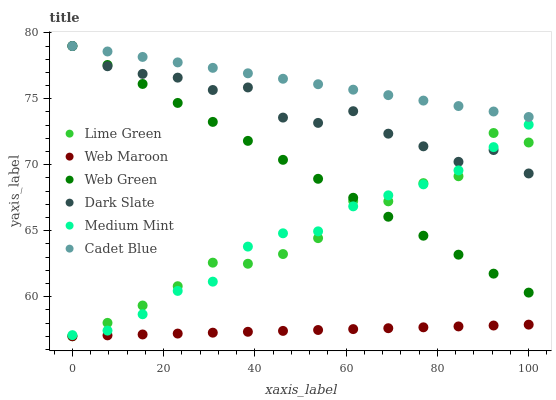Does Web Maroon have the minimum area under the curve?
Answer yes or no. Yes. Does Cadet Blue have the maximum area under the curve?
Answer yes or no. Yes. Does Cadet Blue have the minimum area under the curve?
Answer yes or no. No. Does Web Maroon have the maximum area under the curve?
Answer yes or no. No. Is Web Maroon the smoothest?
Answer yes or no. Yes. Is Lime Green the roughest?
Answer yes or no. Yes. Is Cadet Blue the smoothest?
Answer yes or no. No. Is Cadet Blue the roughest?
Answer yes or no. No. Does Web Maroon have the lowest value?
Answer yes or no. Yes. Does Cadet Blue have the lowest value?
Answer yes or no. No. Does Dark Slate have the highest value?
Answer yes or no. Yes. Does Web Maroon have the highest value?
Answer yes or no. No. Is Web Maroon less than Dark Slate?
Answer yes or no. Yes. Is Medium Mint greater than Web Maroon?
Answer yes or no. Yes. Does Web Green intersect Cadet Blue?
Answer yes or no. Yes. Is Web Green less than Cadet Blue?
Answer yes or no. No. Is Web Green greater than Cadet Blue?
Answer yes or no. No. Does Web Maroon intersect Dark Slate?
Answer yes or no. No. 